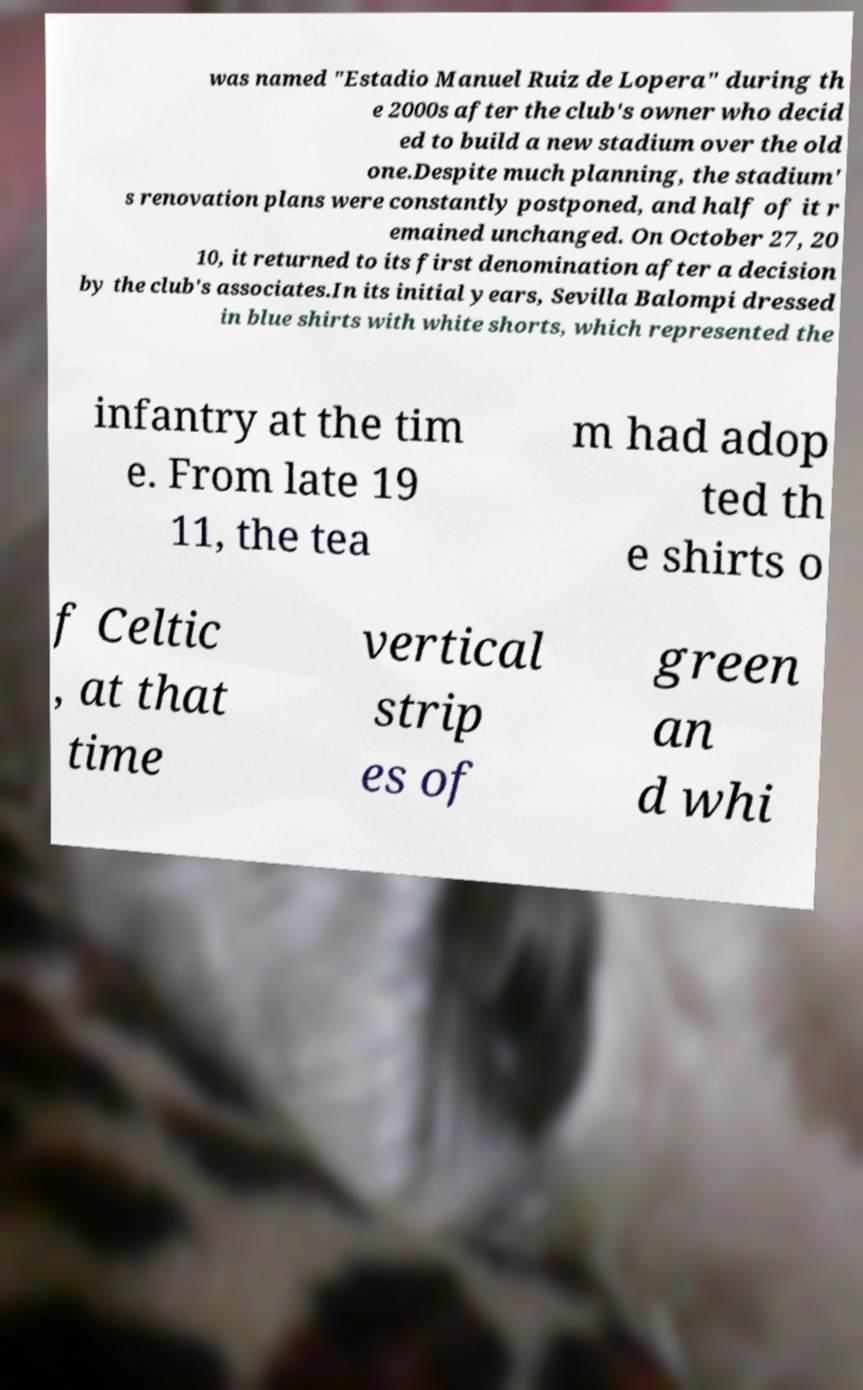Could you assist in decoding the text presented in this image and type it out clearly? was named "Estadio Manuel Ruiz de Lopera" during th e 2000s after the club's owner who decid ed to build a new stadium over the old one.Despite much planning, the stadium' s renovation plans were constantly postponed, and half of it r emained unchanged. On October 27, 20 10, it returned to its first denomination after a decision by the club's associates.In its initial years, Sevilla Balompi dressed in blue shirts with white shorts, which represented the infantry at the tim e. From late 19 11, the tea m had adop ted th e shirts o f Celtic , at that time vertical strip es of green an d whi 